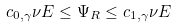Convert formula to latex. <formula><loc_0><loc_0><loc_500><loc_500>c _ { 0 , \gamma } \nu E \leq \Psi _ { R } \leq c _ { 1 , \gamma } \nu E \,</formula> 